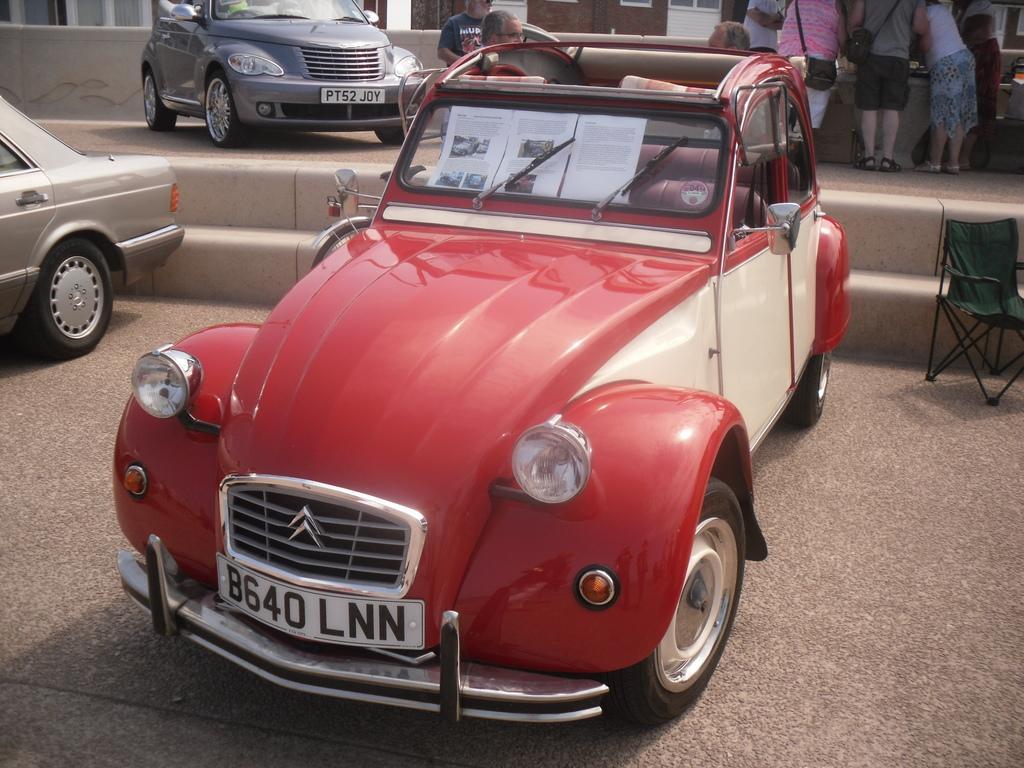In one or two sentences, can you explain what this image depicts? In the image there are three cars, behind the first car there are few people standing and on the right side there is an empty chair kept on the ground. 